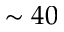Convert formula to latex. <formula><loc_0><loc_0><loc_500><loc_500>\sim 4 0</formula> 